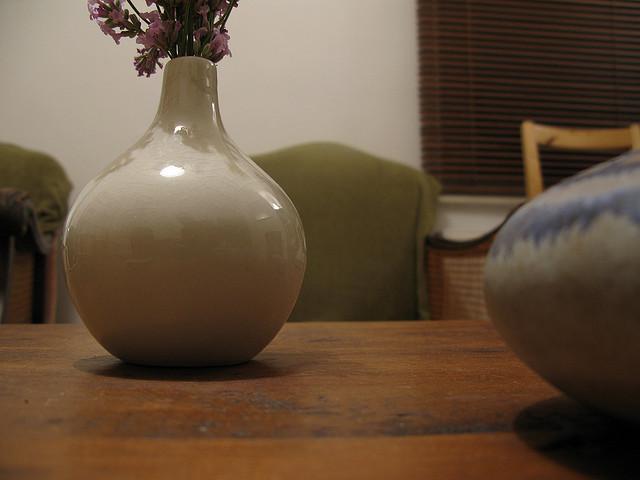How many flower pots are there?
Answer briefly. 1. Are there flowers in the vases?
Short answer required. Yes. What is on the table?
Write a very short answer. Vase. Are the slats on the window shade vertical?
Write a very short answer. No. What shape is the vase?
Short answer required. Round. When were the flowers in the vase watered last?
Be succinct. Yesterday. 